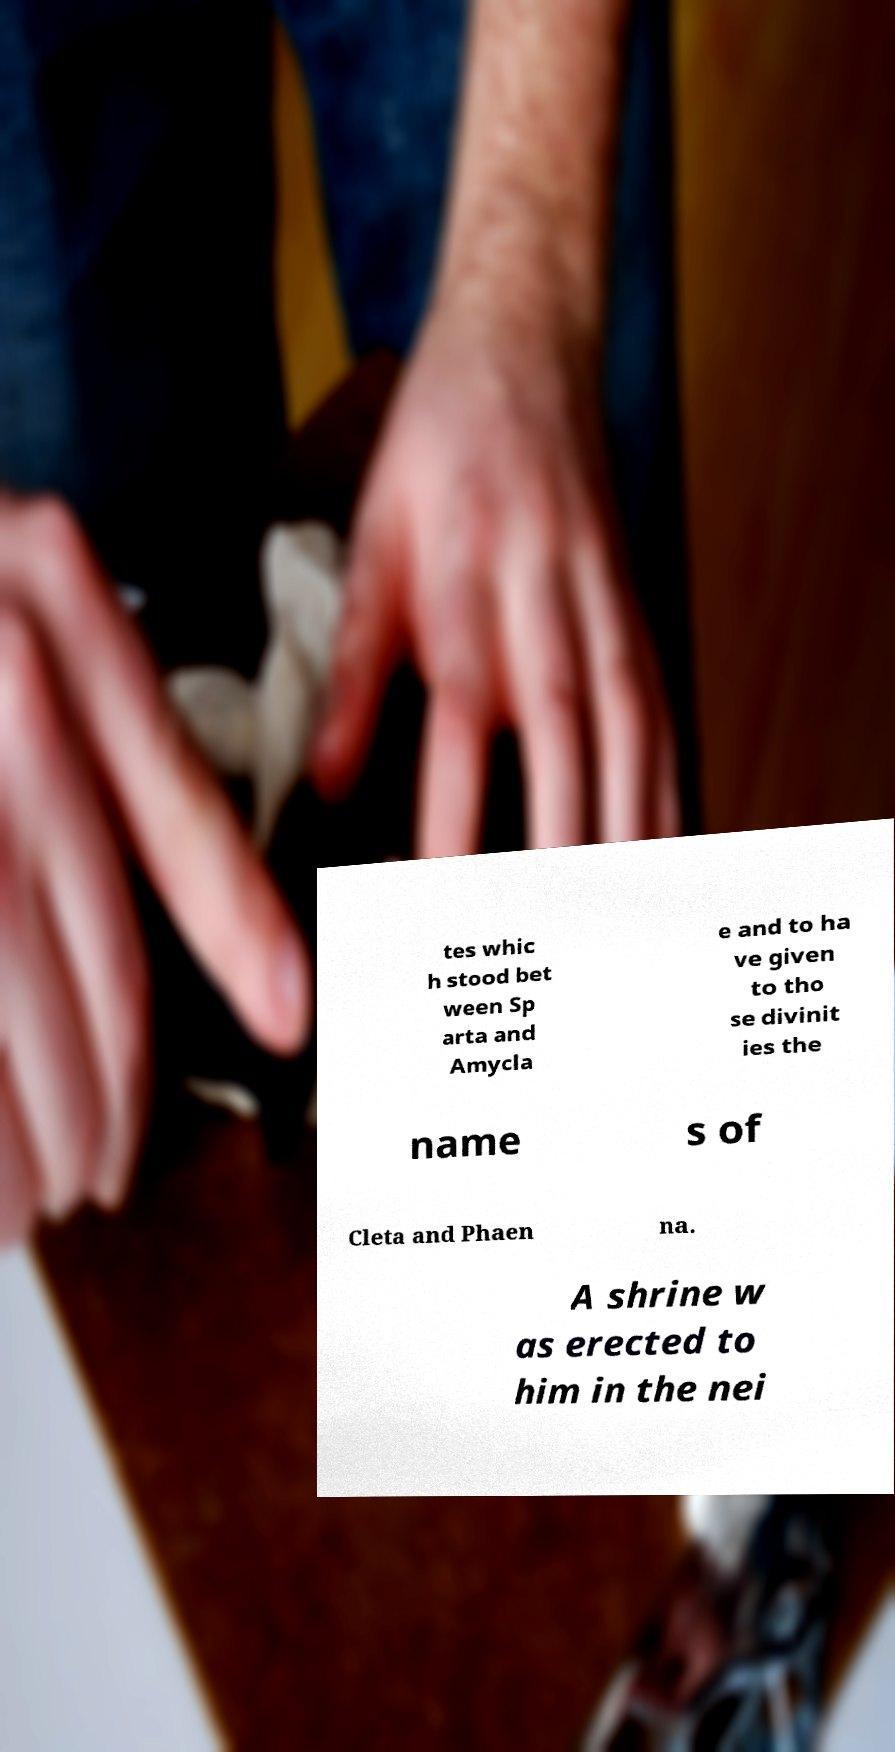For documentation purposes, I need the text within this image transcribed. Could you provide that? tes whic h stood bet ween Sp arta and Amycla e and to ha ve given to tho se divinit ies the name s of Cleta and Phaen na. A shrine w as erected to him in the nei 